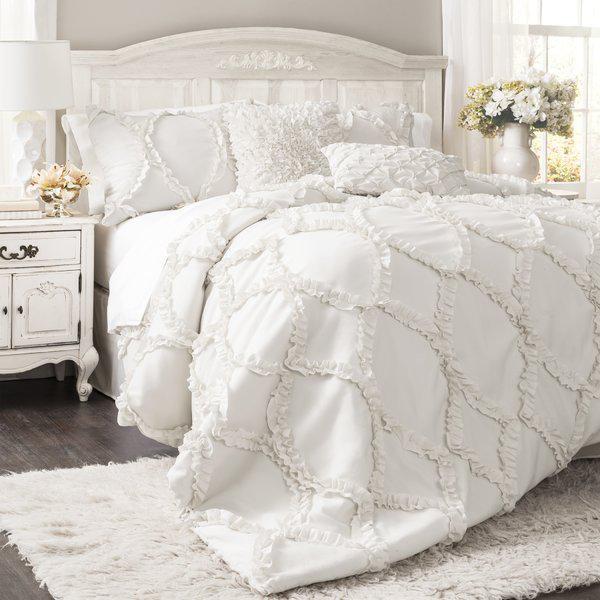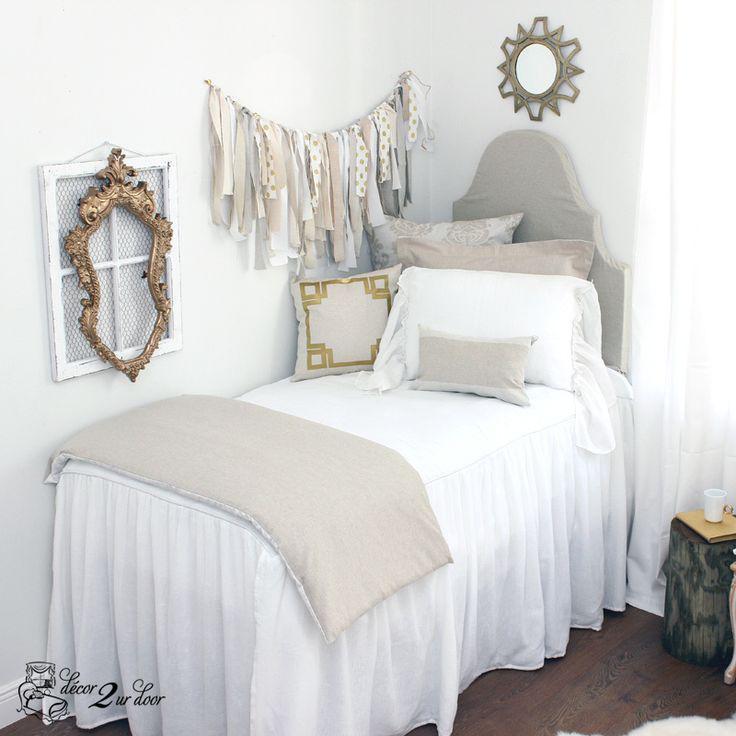The first image is the image on the left, the second image is the image on the right. Examine the images to the left and right. Is the description "An image features a pillow-piled bed with a neutral-colored tufted headboard." accurate? Answer yes or no. No. The first image is the image on the left, the second image is the image on the right. For the images shown, is this caption "Two beds, one of them much narrower than the other, have luxurious white and light-colored bedding and pillows." true? Answer yes or no. Yes. 